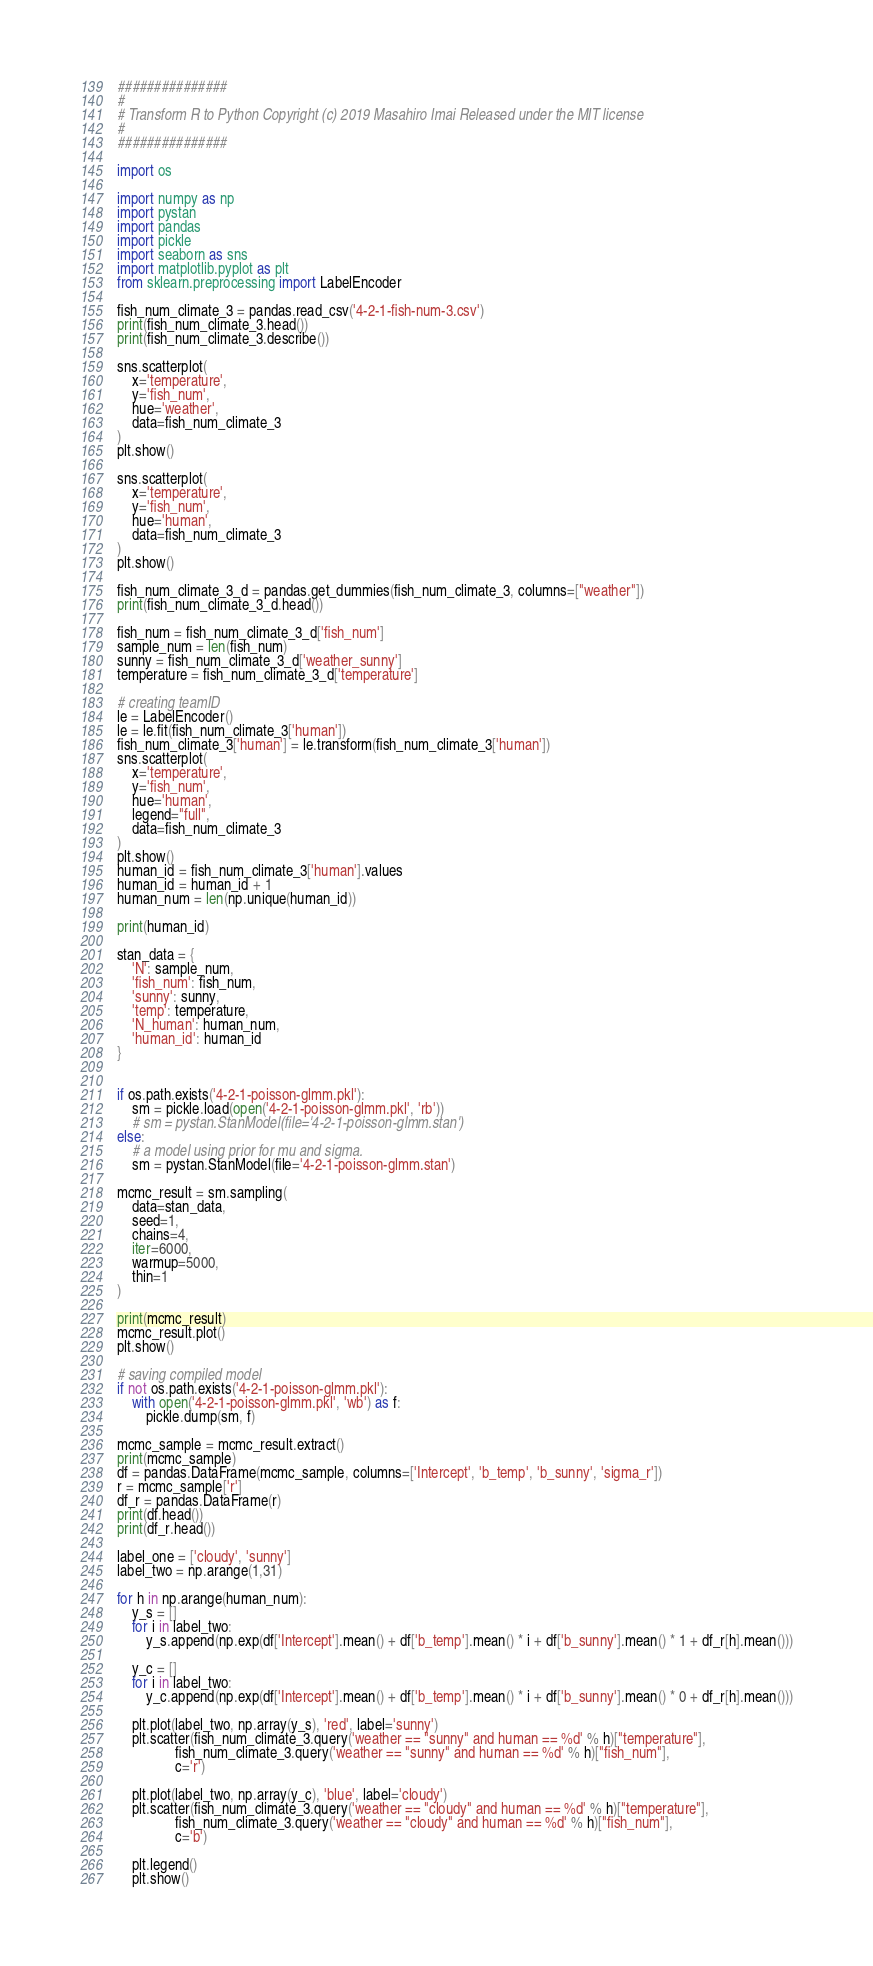Convert code to text. <code><loc_0><loc_0><loc_500><loc_500><_Python_>###############
#
# Transform R to Python Copyright (c) 2019 Masahiro Imai Released under the MIT license
#
###############

import os

import numpy as np
import pystan
import pandas
import pickle
import seaborn as sns
import matplotlib.pyplot as plt
from sklearn.preprocessing import LabelEncoder

fish_num_climate_3 = pandas.read_csv('4-2-1-fish-num-3.csv')
print(fish_num_climate_3.head())
print(fish_num_climate_3.describe())

sns.scatterplot(
    x='temperature',
    y='fish_num',
    hue='weather',
    data=fish_num_climate_3
)
plt.show()

sns.scatterplot(
    x='temperature',
    y='fish_num',
    hue='human',
    data=fish_num_climate_3
)
plt.show()

fish_num_climate_3_d = pandas.get_dummies(fish_num_climate_3, columns=["weather"])
print(fish_num_climate_3_d.head())

fish_num = fish_num_climate_3_d['fish_num']
sample_num = len(fish_num)
sunny = fish_num_climate_3_d['weather_sunny']
temperature = fish_num_climate_3_d['temperature']

# creating teamID
le = LabelEncoder()
le = le.fit(fish_num_climate_3['human'])
fish_num_climate_3['human'] = le.transform(fish_num_climate_3['human'])
sns.scatterplot(
    x='temperature',
    y='fish_num',
    hue='human',
    legend="full",
    data=fish_num_climate_3
)
plt.show()
human_id = fish_num_climate_3['human'].values
human_id = human_id + 1
human_num = len(np.unique(human_id))

print(human_id)

stan_data = {
    'N': sample_num,
    'fish_num': fish_num,
    'sunny': sunny,
    'temp': temperature,
    'N_human': human_num,
    'human_id': human_id
}


if os.path.exists('4-2-1-poisson-glmm.pkl'):
    sm = pickle.load(open('4-2-1-poisson-glmm.pkl', 'rb'))
    # sm = pystan.StanModel(file='4-2-1-poisson-glmm.stan')
else:
    # a model using prior for mu and sigma.
    sm = pystan.StanModel(file='4-2-1-poisson-glmm.stan')

mcmc_result = sm.sampling(
    data=stan_data,
    seed=1,
    chains=4,
    iter=6000,
    warmup=5000,
    thin=1
)

print(mcmc_result)
mcmc_result.plot()
plt.show()

# saving compiled model
if not os.path.exists('4-2-1-poisson-glmm.pkl'):
    with open('4-2-1-poisson-glmm.pkl', 'wb') as f:
        pickle.dump(sm, f)

mcmc_sample = mcmc_result.extract()
print(mcmc_sample)
df = pandas.DataFrame(mcmc_sample, columns=['Intercept', 'b_temp', 'b_sunny', 'sigma_r'])
r = mcmc_sample['r']
df_r = pandas.DataFrame(r)
print(df.head())
print(df_r.head())

label_one = ['cloudy', 'sunny']
label_two = np.arange(1,31)

for h in np.arange(human_num):
    y_s = []
    for i in label_two:
        y_s.append(np.exp(df['Intercept'].mean() + df['b_temp'].mean() * i + df['b_sunny'].mean() * 1 + df_r[h].mean()))

    y_c = []
    for i in label_two:
        y_c.append(np.exp(df['Intercept'].mean() + df['b_temp'].mean() * i + df['b_sunny'].mean() * 0 + df_r[h].mean()))

    plt.plot(label_two, np.array(y_s), 'red', label='sunny')
    plt.scatter(fish_num_climate_3.query('weather == "sunny" and human == %d' % h)["temperature"],
                fish_num_climate_3.query('weather == "sunny" and human == %d' % h)["fish_num"],
                c='r')

    plt.plot(label_two, np.array(y_c), 'blue', label='cloudy')
    plt.scatter(fish_num_climate_3.query('weather == "cloudy" and human == %d' % h)["temperature"],
                fish_num_climate_3.query('weather == "cloudy" and human == %d' % h)["fish_num"],
                c='b')

    plt.legend()
    plt.show()</code> 